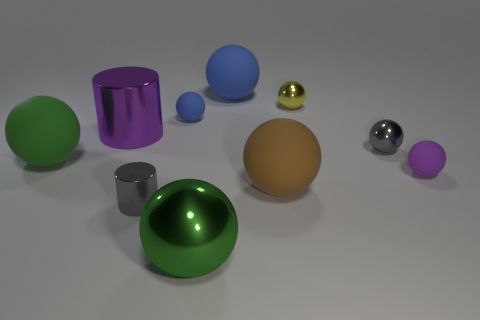Subtract all gray shiny spheres. How many spheres are left? 7 Subtract all green balls. How many balls are left? 6 Subtract all balls. How many objects are left? 2 Subtract all yellow balls. How many gray cylinders are left? 1 Subtract all big rubber balls. Subtract all big metal cylinders. How many objects are left? 6 Add 1 purple spheres. How many purple spheres are left? 2 Add 7 rubber cylinders. How many rubber cylinders exist? 7 Subtract 1 purple cylinders. How many objects are left? 9 Subtract 4 spheres. How many spheres are left? 4 Subtract all green spheres. Subtract all yellow cubes. How many spheres are left? 6 